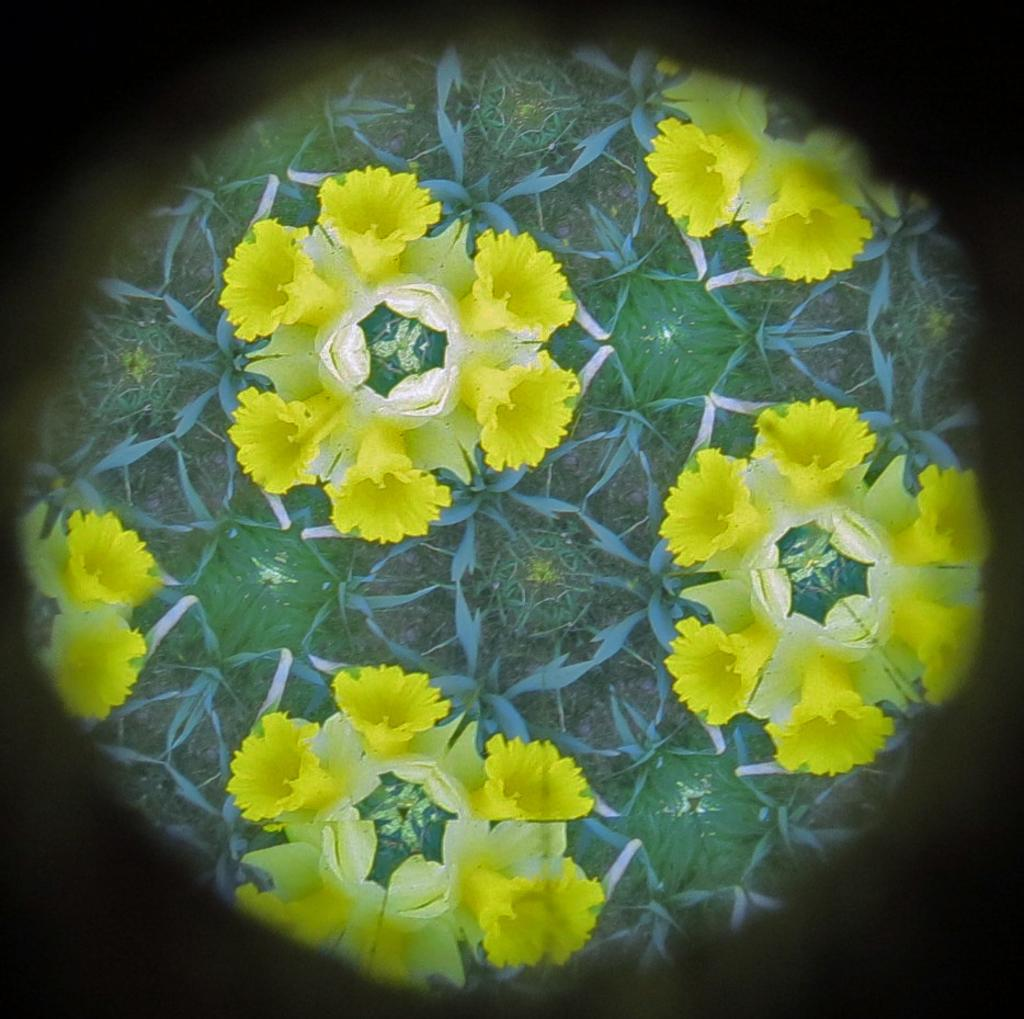What color are the flowers in the image? The flowers in the image are yellow. What color are the leaves in the image? The leaves in the image are green. How many fingers can be seen holding the flowers in the image? There are no fingers or hands visible in the image; it only shows flowers and leaves. 